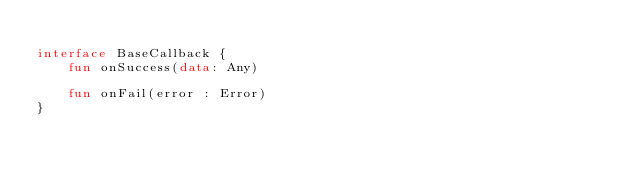Convert code to text. <code><loc_0><loc_0><loc_500><loc_500><_Kotlin_>
interface BaseCallback {
    fun onSuccess(data: Any)

    fun onFail(error : Error)
}
</code> 